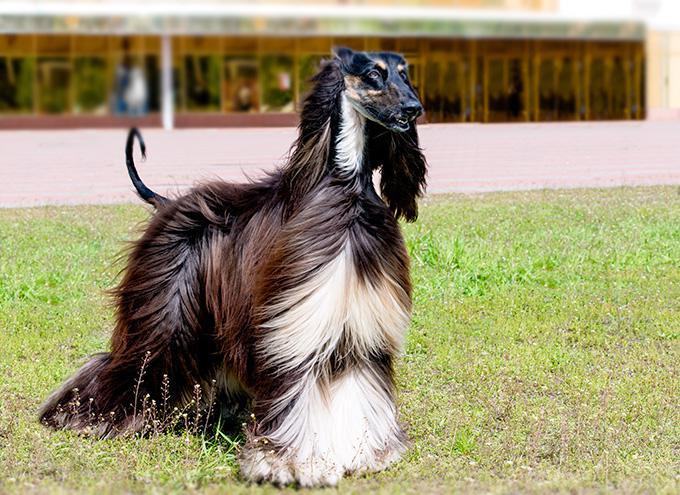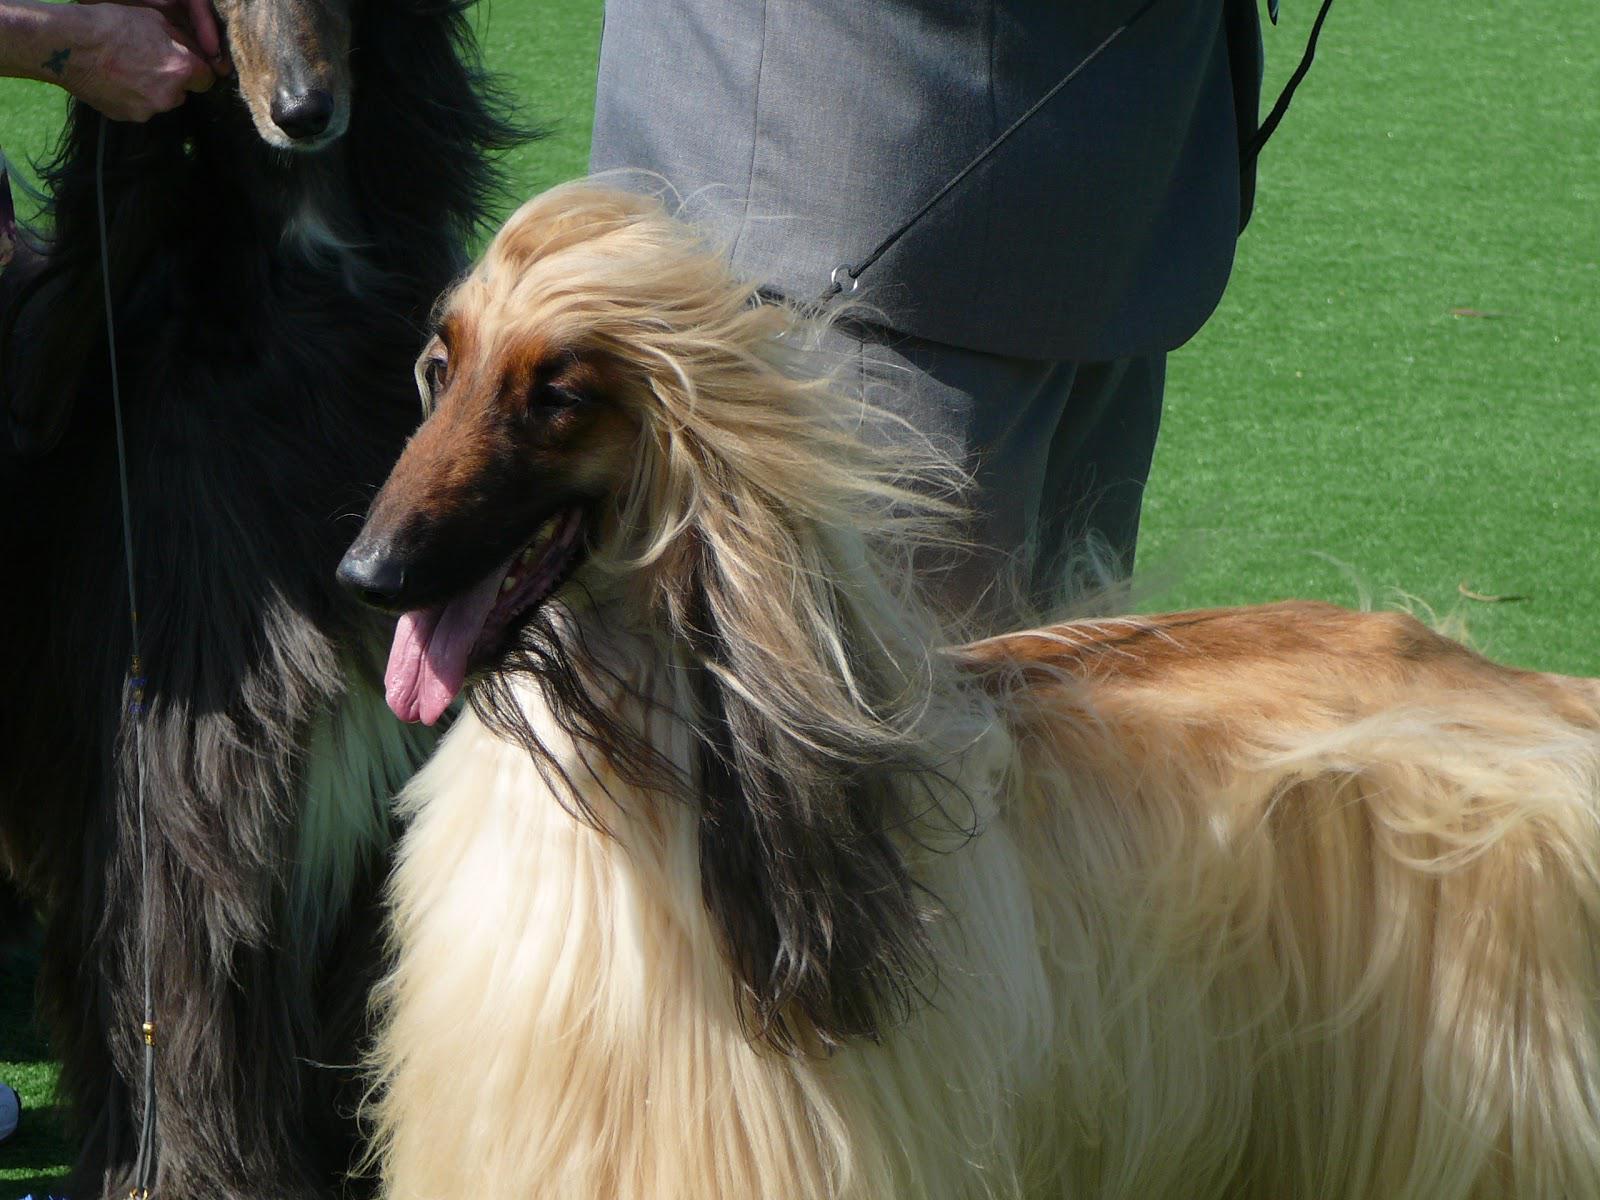The first image is the image on the left, the second image is the image on the right. Evaluate the accuracy of this statement regarding the images: "One of the images contains two of the afghan hounds.". Is it true? Answer yes or no. Yes. The first image is the image on the left, the second image is the image on the right. Examine the images to the left and right. Is the description "There are two Afghan Hounds outside in the right image." accurate? Answer yes or no. Yes. 